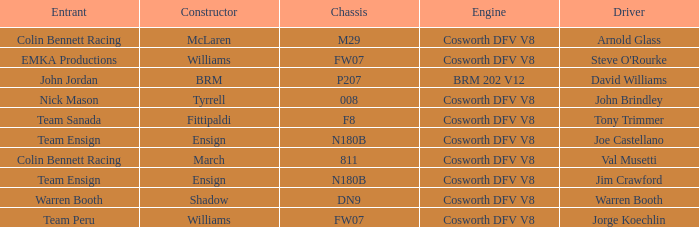What team used the BRM built car? John Jordan. 